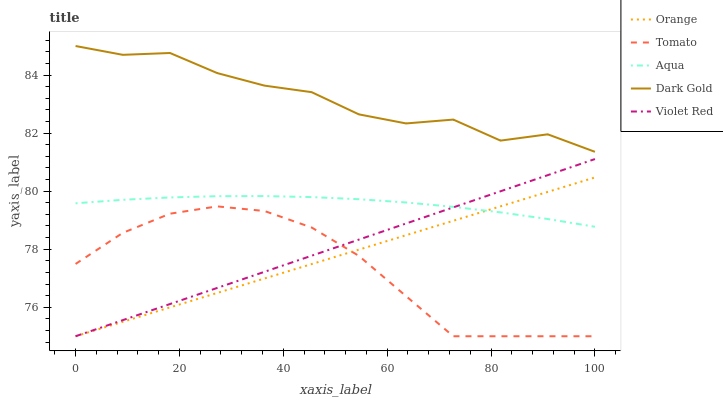Does Tomato have the minimum area under the curve?
Answer yes or no. Yes. Does Dark Gold have the maximum area under the curve?
Answer yes or no. Yes. Does Violet Red have the minimum area under the curve?
Answer yes or no. No. Does Violet Red have the maximum area under the curve?
Answer yes or no. No. Is Orange the smoothest?
Answer yes or no. Yes. Is Dark Gold the roughest?
Answer yes or no. Yes. Is Tomato the smoothest?
Answer yes or no. No. Is Tomato the roughest?
Answer yes or no. No. Does Orange have the lowest value?
Answer yes or no. Yes. Does Aqua have the lowest value?
Answer yes or no. No. Does Dark Gold have the highest value?
Answer yes or no. Yes. Does Violet Red have the highest value?
Answer yes or no. No. Is Tomato less than Aqua?
Answer yes or no. Yes. Is Dark Gold greater than Violet Red?
Answer yes or no. Yes. Does Tomato intersect Violet Red?
Answer yes or no. Yes. Is Tomato less than Violet Red?
Answer yes or no. No. Is Tomato greater than Violet Red?
Answer yes or no. No. Does Tomato intersect Aqua?
Answer yes or no. No. 